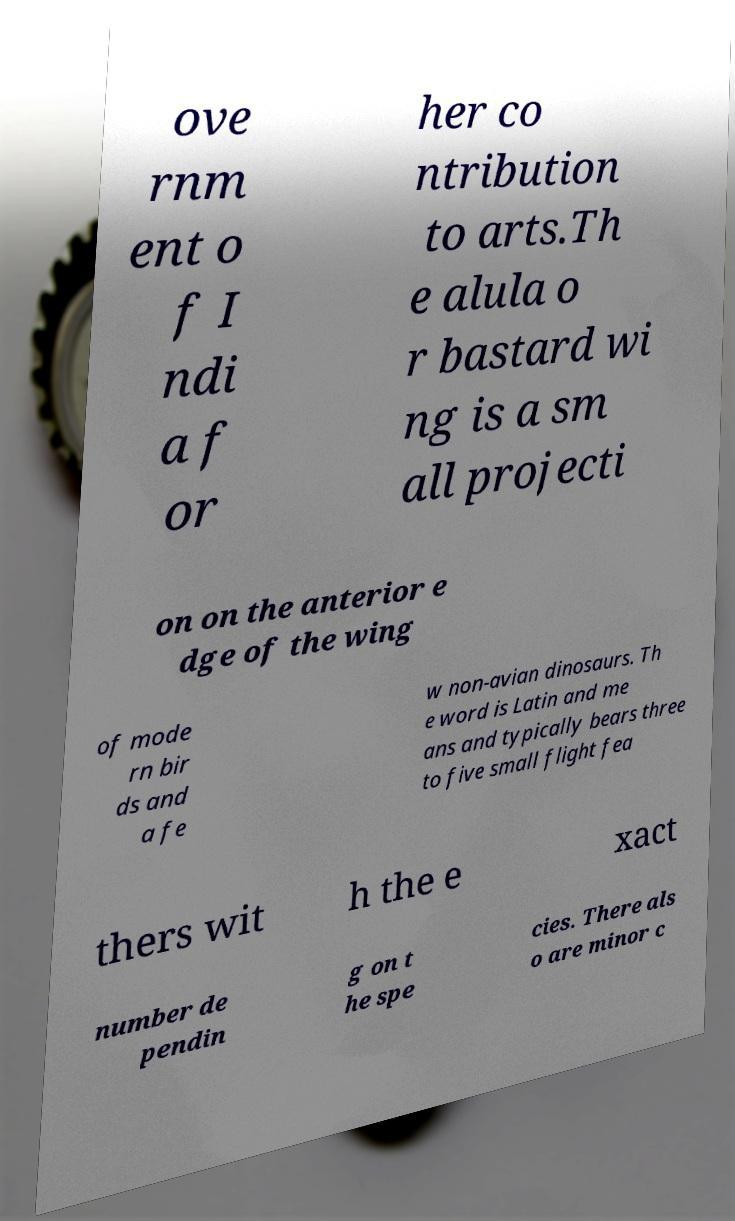For documentation purposes, I need the text within this image transcribed. Could you provide that? ove rnm ent o f I ndi a f or her co ntribution to arts.Th e alula o r bastard wi ng is a sm all projecti on on the anterior e dge of the wing of mode rn bir ds and a fe w non-avian dinosaurs. Th e word is Latin and me ans and typically bears three to five small flight fea thers wit h the e xact number de pendin g on t he spe cies. There als o are minor c 